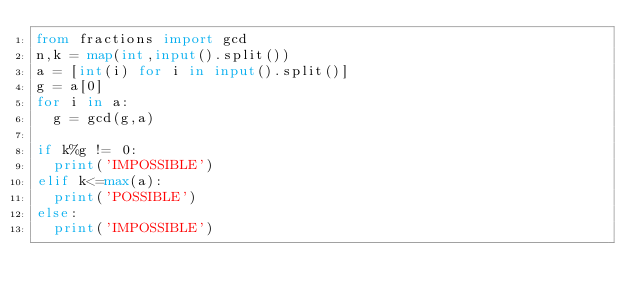<code> <loc_0><loc_0><loc_500><loc_500><_Python_>from fractions import gcd
n,k = map(int,input().split())
a = [int(i) for i in input().split()]
g = a[0]
for i in a:
  g = gcd(g,a)
  
if k%g != 0:
  print('IMPOSSIBLE')
elif k<=max(a):
  print('POSSIBLE')
else:
  print('IMPOSSIBLE')</code> 